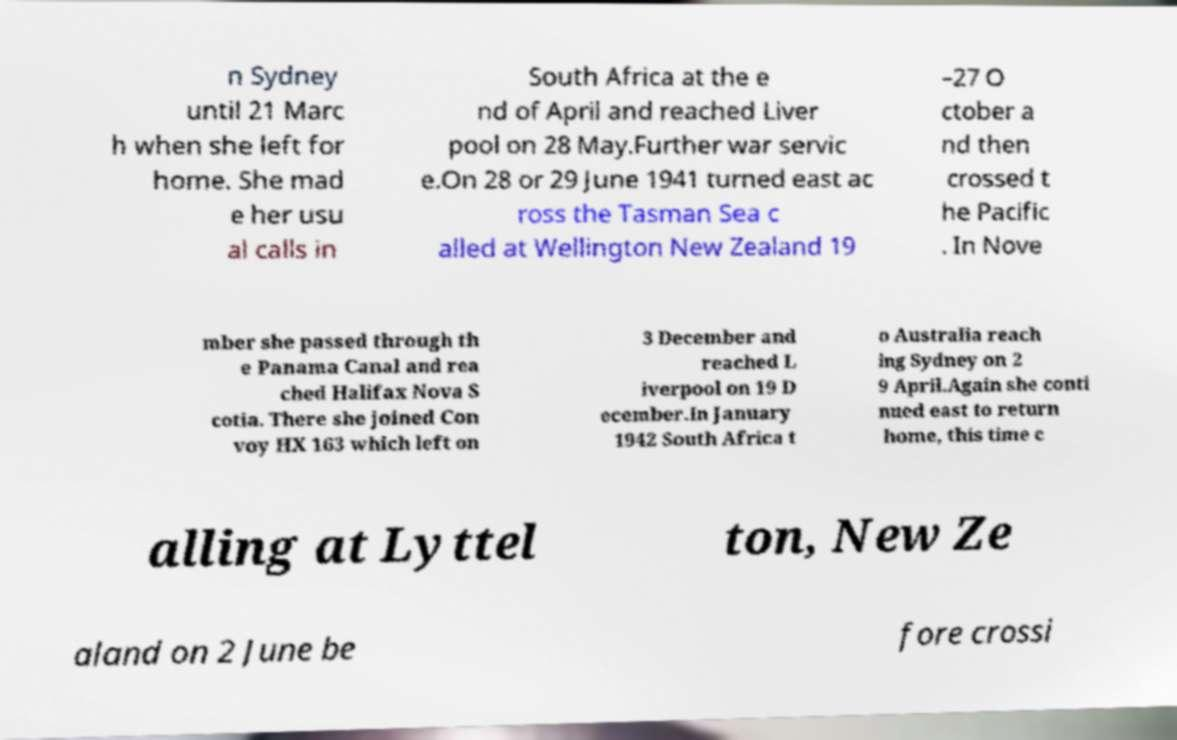Could you extract and type out the text from this image? n Sydney until 21 Marc h when she left for home. She mad e her usu al calls in South Africa at the e nd of April and reached Liver pool on 28 May.Further war servic e.On 28 or 29 June 1941 turned east ac ross the Tasman Sea c alled at Wellington New Zealand 19 –27 O ctober a nd then crossed t he Pacific . In Nove mber she passed through th e Panama Canal and rea ched Halifax Nova S cotia. There she joined Con voy HX 163 which left on 3 December and reached L iverpool on 19 D ecember.In January 1942 South Africa t o Australia reach ing Sydney on 2 9 April.Again she conti nued east to return home, this time c alling at Lyttel ton, New Ze aland on 2 June be fore crossi 